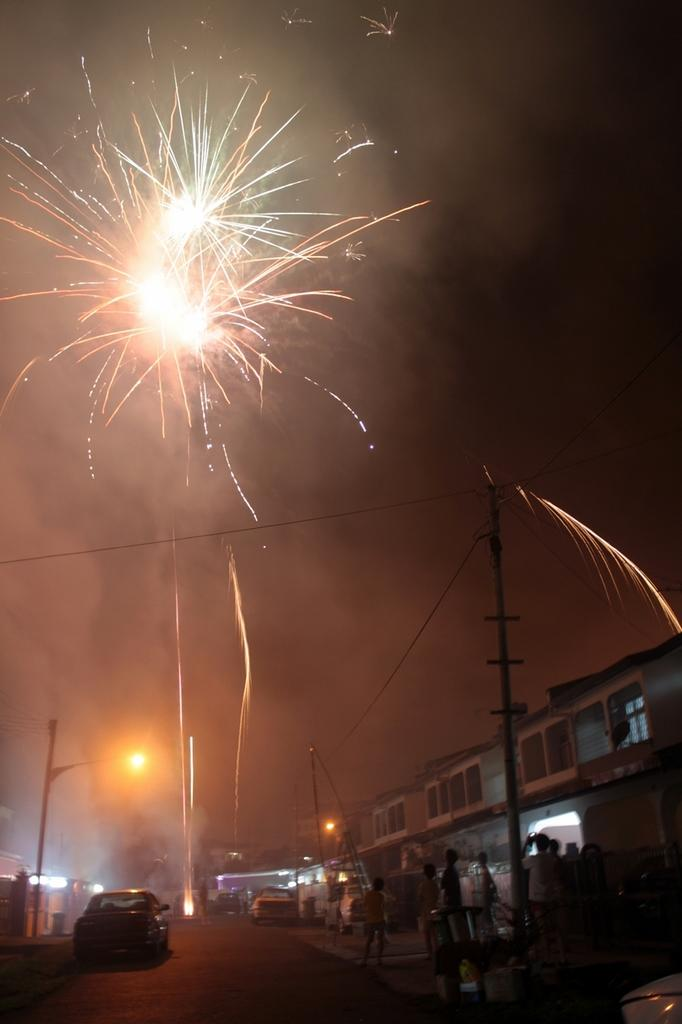What is the main subject of the image? The image shows a view of the road. What can be seen in the right corner of the image? There are small houses and electric poles in the right corner of the image. What is happening in the sky in the image? Burning crackers are visible in the sky. What type of pump can be seen in the image? There is no pump present in the image. 